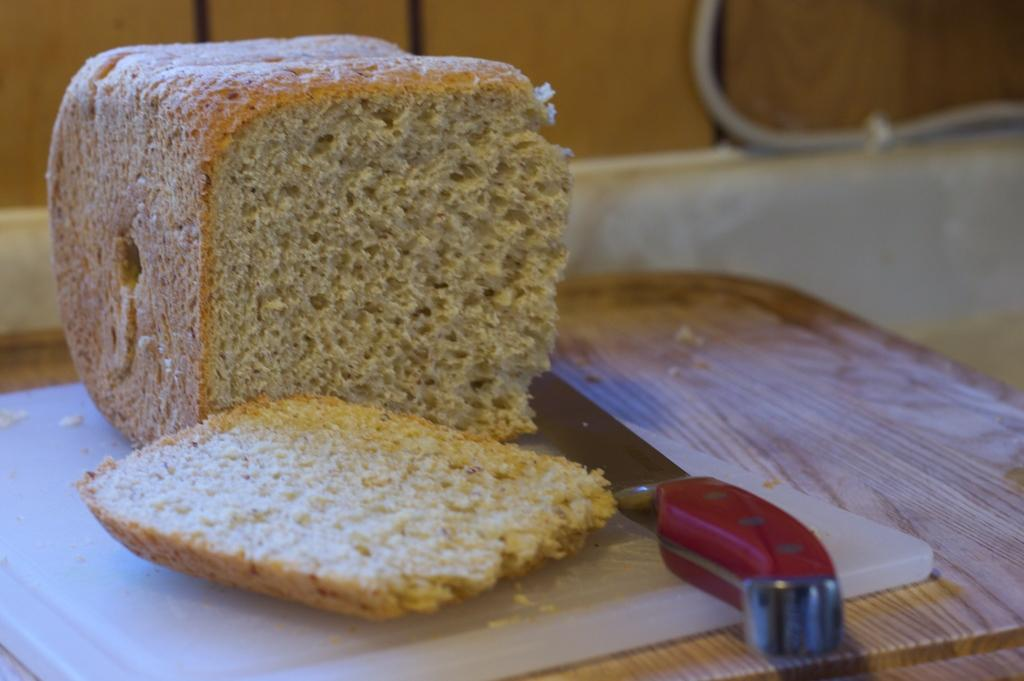What is located at the bottom of the image? There is a table at the bottom of the image. What objects can be seen on the table? There is a knife, bread, and a cutting mat on the table. What is the surface behind the bread? There is a wall behind the bread. How many spiders are crawling on the chin of the person in the image? There is no person present in the image, and therefore no chin or spiders can be observed. 